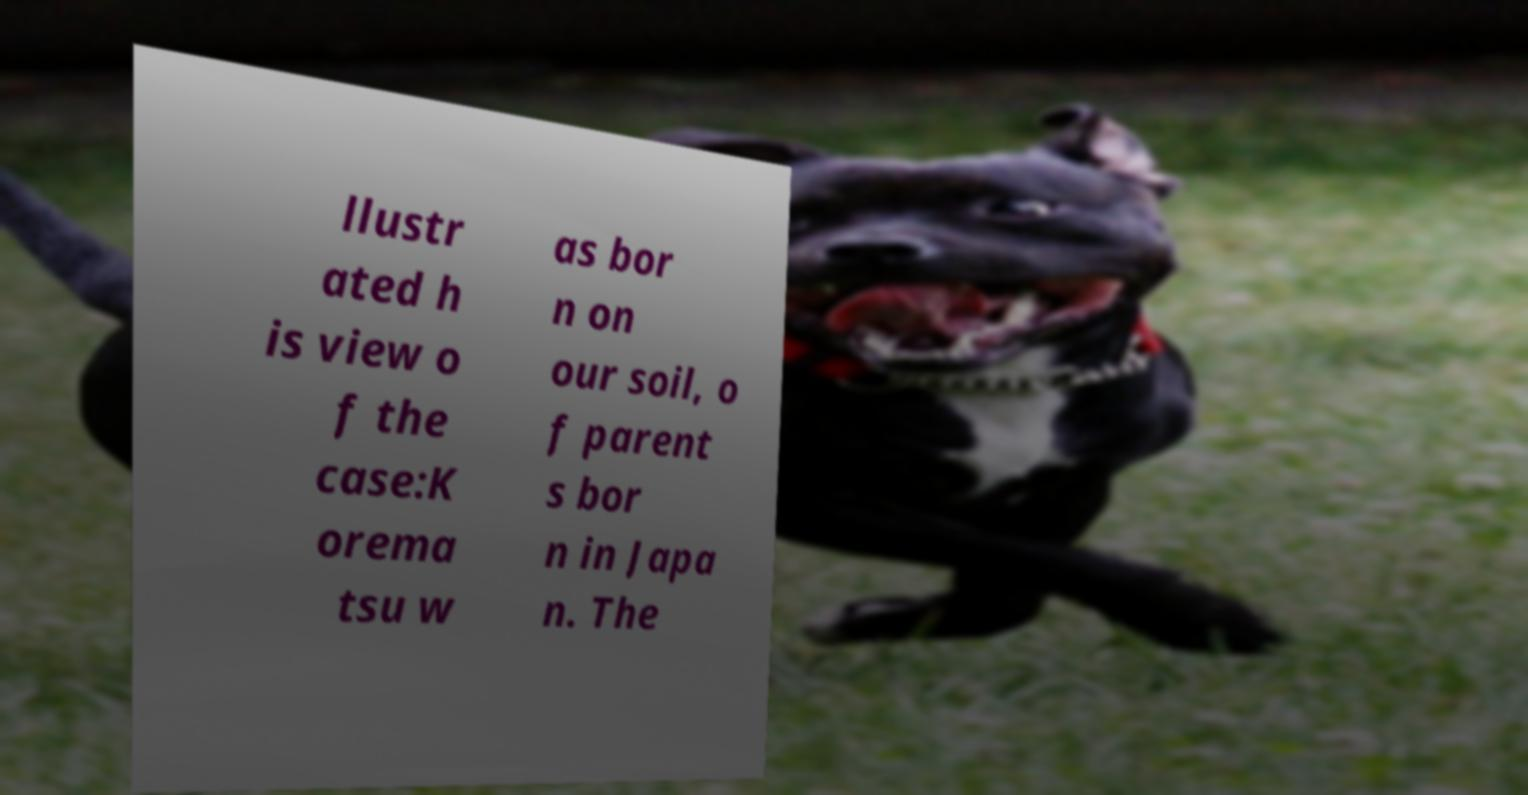I need the written content from this picture converted into text. Can you do that? llustr ated h is view o f the case:K orema tsu w as bor n on our soil, o f parent s bor n in Japa n. The 